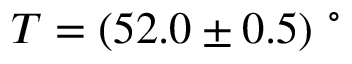Convert formula to latex. <formula><loc_0><loc_0><loc_500><loc_500>T = ( 5 2 . 0 \pm 0 . 5 ) \ ^ { \circ }</formula> 